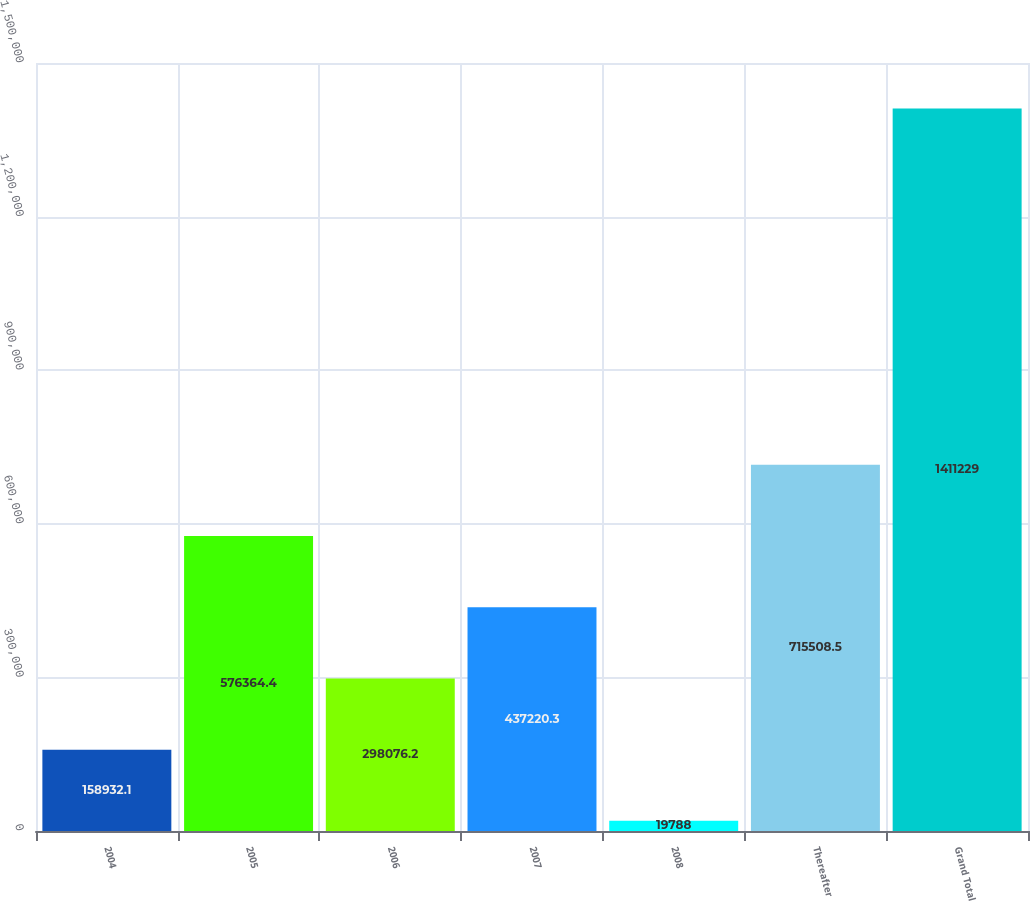Convert chart to OTSL. <chart><loc_0><loc_0><loc_500><loc_500><bar_chart><fcel>2004<fcel>2005<fcel>2006<fcel>2007<fcel>2008<fcel>Thereafter<fcel>Grand Total<nl><fcel>158932<fcel>576364<fcel>298076<fcel>437220<fcel>19788<fcel>715508<fcel>1.41123e+06<nl></chart> 